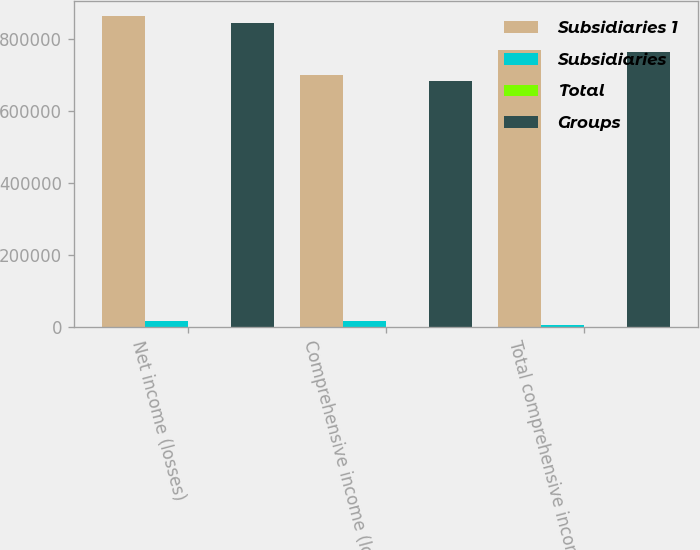Convert chart to OTSL. <chart><loc_0><loc_0><loc_500><loc_500><stacked_bar_chart><ecel><fcel>Net income (losses)<fcel>Comprehensive income (losses)<fcel>Total comprehensive income<nl><fcel>Subsidiaries 1<fcel>863330<fcel>700742<fcel>769853<nl><fcel>Subsidiaries<fcel>17257<fcel>17257<fcel>4481<nl><fcel>Total<fcel>308<fcel>308<fcel>274<nl><fcel>Groups<fcel>846381<fcel>683793<fcel>765646<nl></chart> 